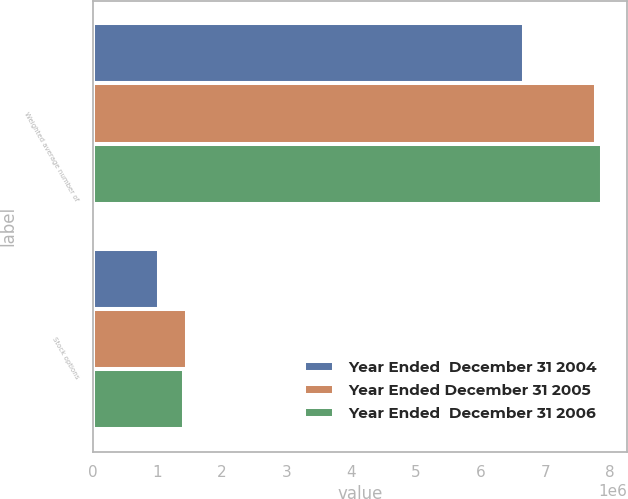Convert chart to OTSL. <chart><loc_0><loc_0><loc_500><loc_500><stacked_bar_chart><ecel><fcel>Weighted average number of<fcel>Stock options<nl><fcel>Year Ended  December 31 2004<fcel>6.67157e+06<fcel>1.0275e+06<nl><fcel>Year Ended December 31 2005<fcel>7.78438e+06<fcel>1.46353e+06<nl><fcel>Year Ended  December 31 2006<fcel>7.87687e+06<fcel>1.40426e+06<nl></chart> 